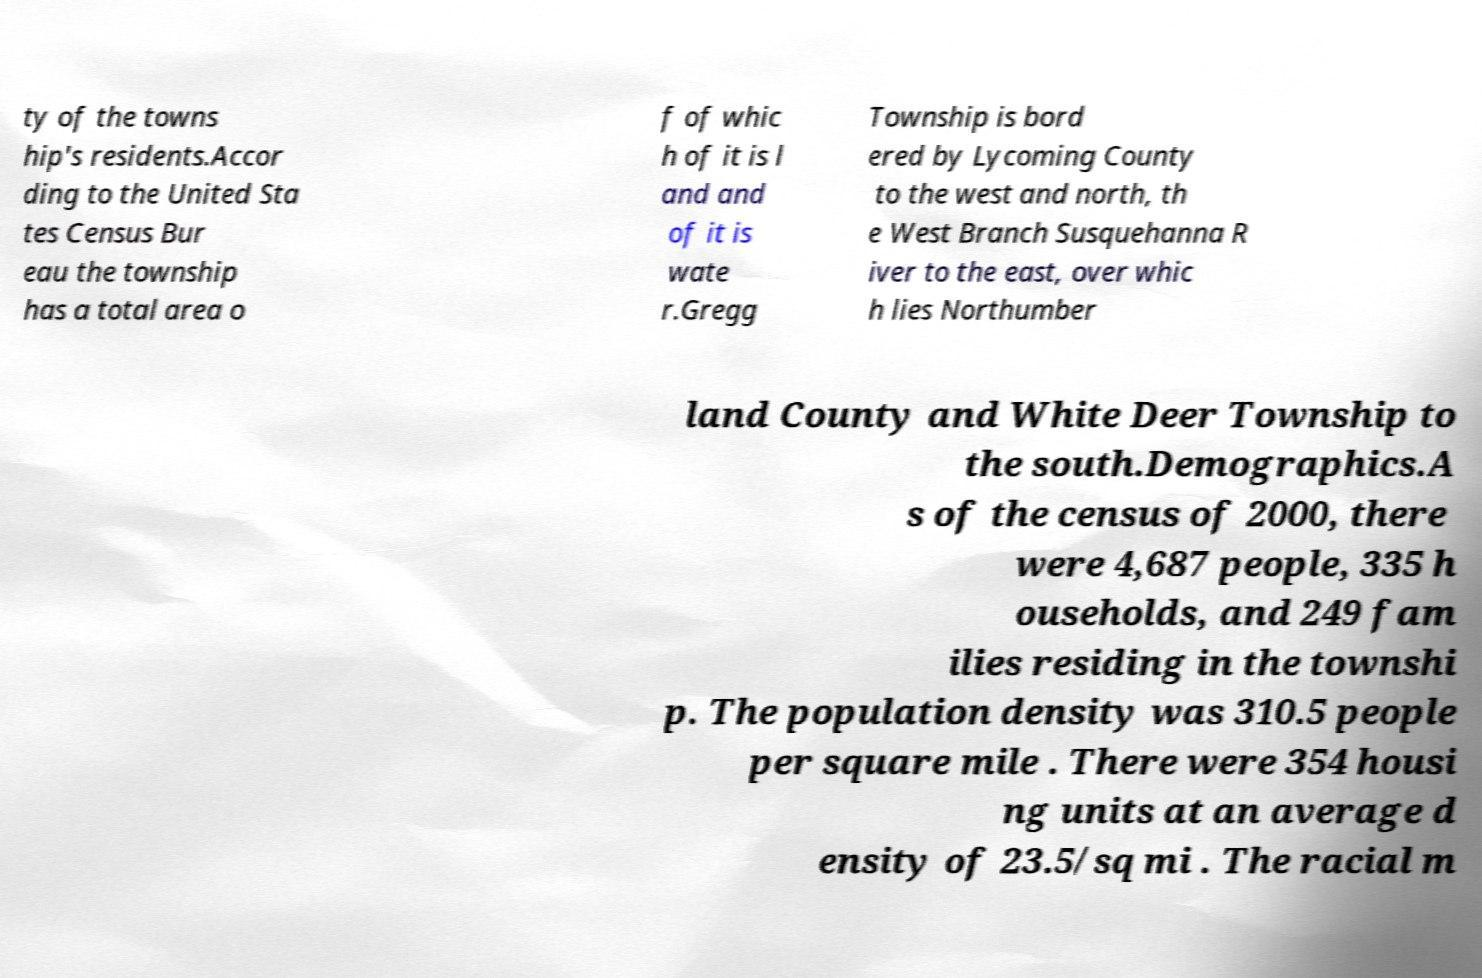What messages or text are displayed in this image? I need them in a readable, typed format. ty of the towns hip's residents.Accor ding to the United Sta tes Census Bur eau the township has a total area o f of whic h of it is l and and of it is wate r.Gregg Township is bord ered by Lycoming County to the west and north, th e West Branch Susquehanna R iver to the east, over whic h lies Northumber land County and White Deer Township to the south.Demographics.A s of the census of 2000, there were 4,687 people, 335 h ouseholds, and 249 fam ilies residing in the townshi p. The population density was 310.5 people per square mile . There were 354 housi ng units at an average d ensity of 23.5/sq mi . The racial m 